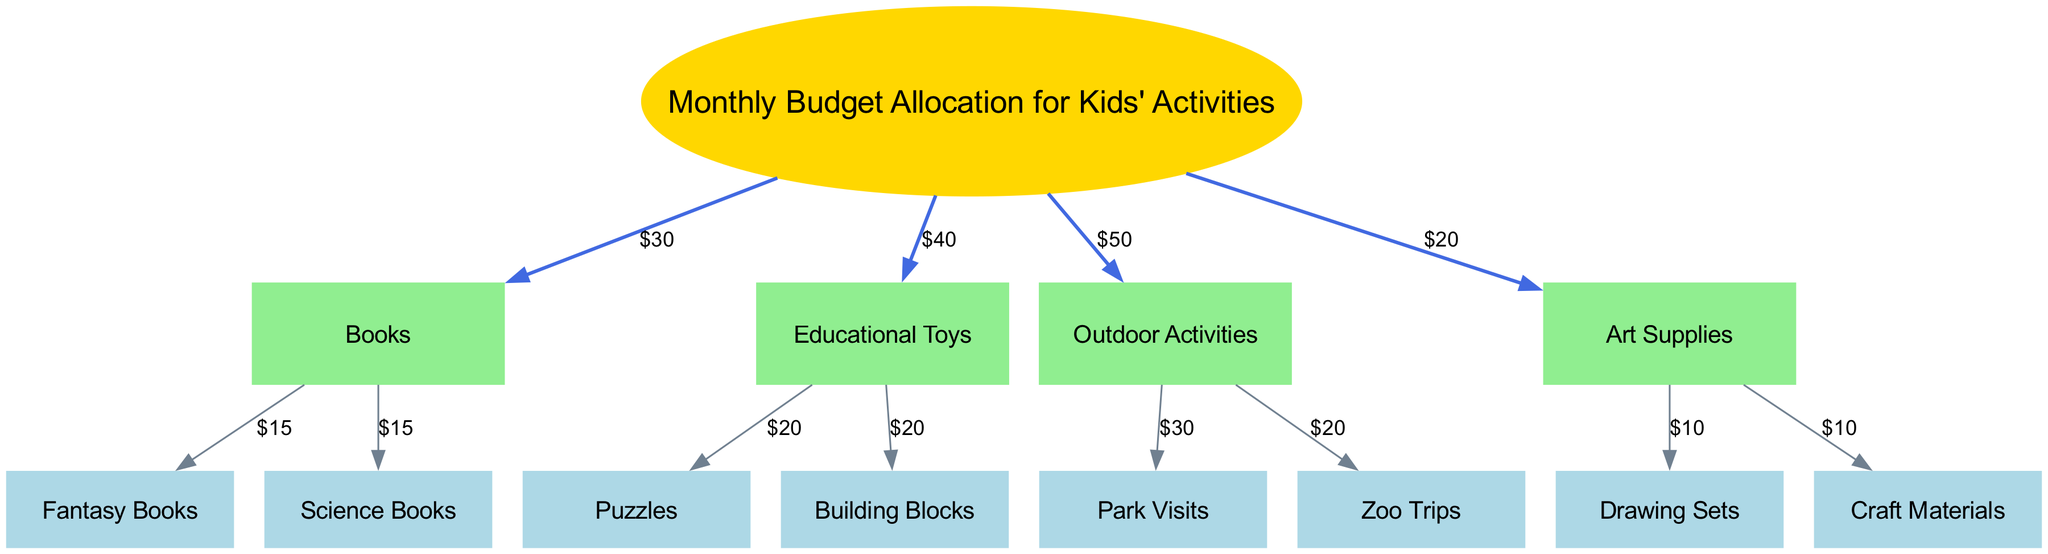What is the total monthly budget allocated for kids' activities? The diagram shows that the monthly budget allocation includes books ($30), educational toys ($40), outdoor activities ($50), and art supplies ($20). Therefore, the total is 30 + 40 + 50 + 20 = 140.
Answer: 140 How much is allocated for outdoor activities? The edge connecting "Budget Allocation for Kids' Activities" to "Outdoor Activities" indicates a cost of $50. This information is explicitly stated in the diagram.
Answer: $50 Which activity receives the lowest budget allocation? The categories represented in the diagram are books, educational toys, outdoor activities, and art supplies. Among these, art supplies, with a budget of $20, has the lowest allocation.
Answer: Art Supplies How much is spent on fantasy books? The diagram states that from the "Books" node, $15 is allocated specifically for "Fantasy Books." This value is clearly labeled on the edge connecting these nodes.
Answer: $15 What percentage of the total budget is spent on educational toys? The budget allocation for educational toys is $40, and the total budget is $140. The percentage is calculated as (40/140) * 100 = 28.57%.
Answer: 28.57% How many types of books are represented in the diagram? The diagram indicates the presence of two categories under the "Books" node: "Fantasy Books" and "Science Books." Therefore, there are 2 types of books depicted in the diagram.
Answer: 2 What are the two items listed under art supplies? In the diagram, under the "Art Supplies" node, there are two edges leading to "Drawing Sets" and "Craft Materials," indicating these are the two items within this category.
Answer: Drawing Sets and Craft Materials What is the total amount allocated to educational toys? The diagram shows two items under educational toys: "Puzzles" and "Building Blocks," each receiving $20. The total allocation is therefore 20 + 20 = 40.
Answer: $40 How much money is allocated for park visits? The edge from "Outdoor Activities" to "Park Visits" indicates a budget of $30, which is directly labeled in the diagram.
Answer: $30 